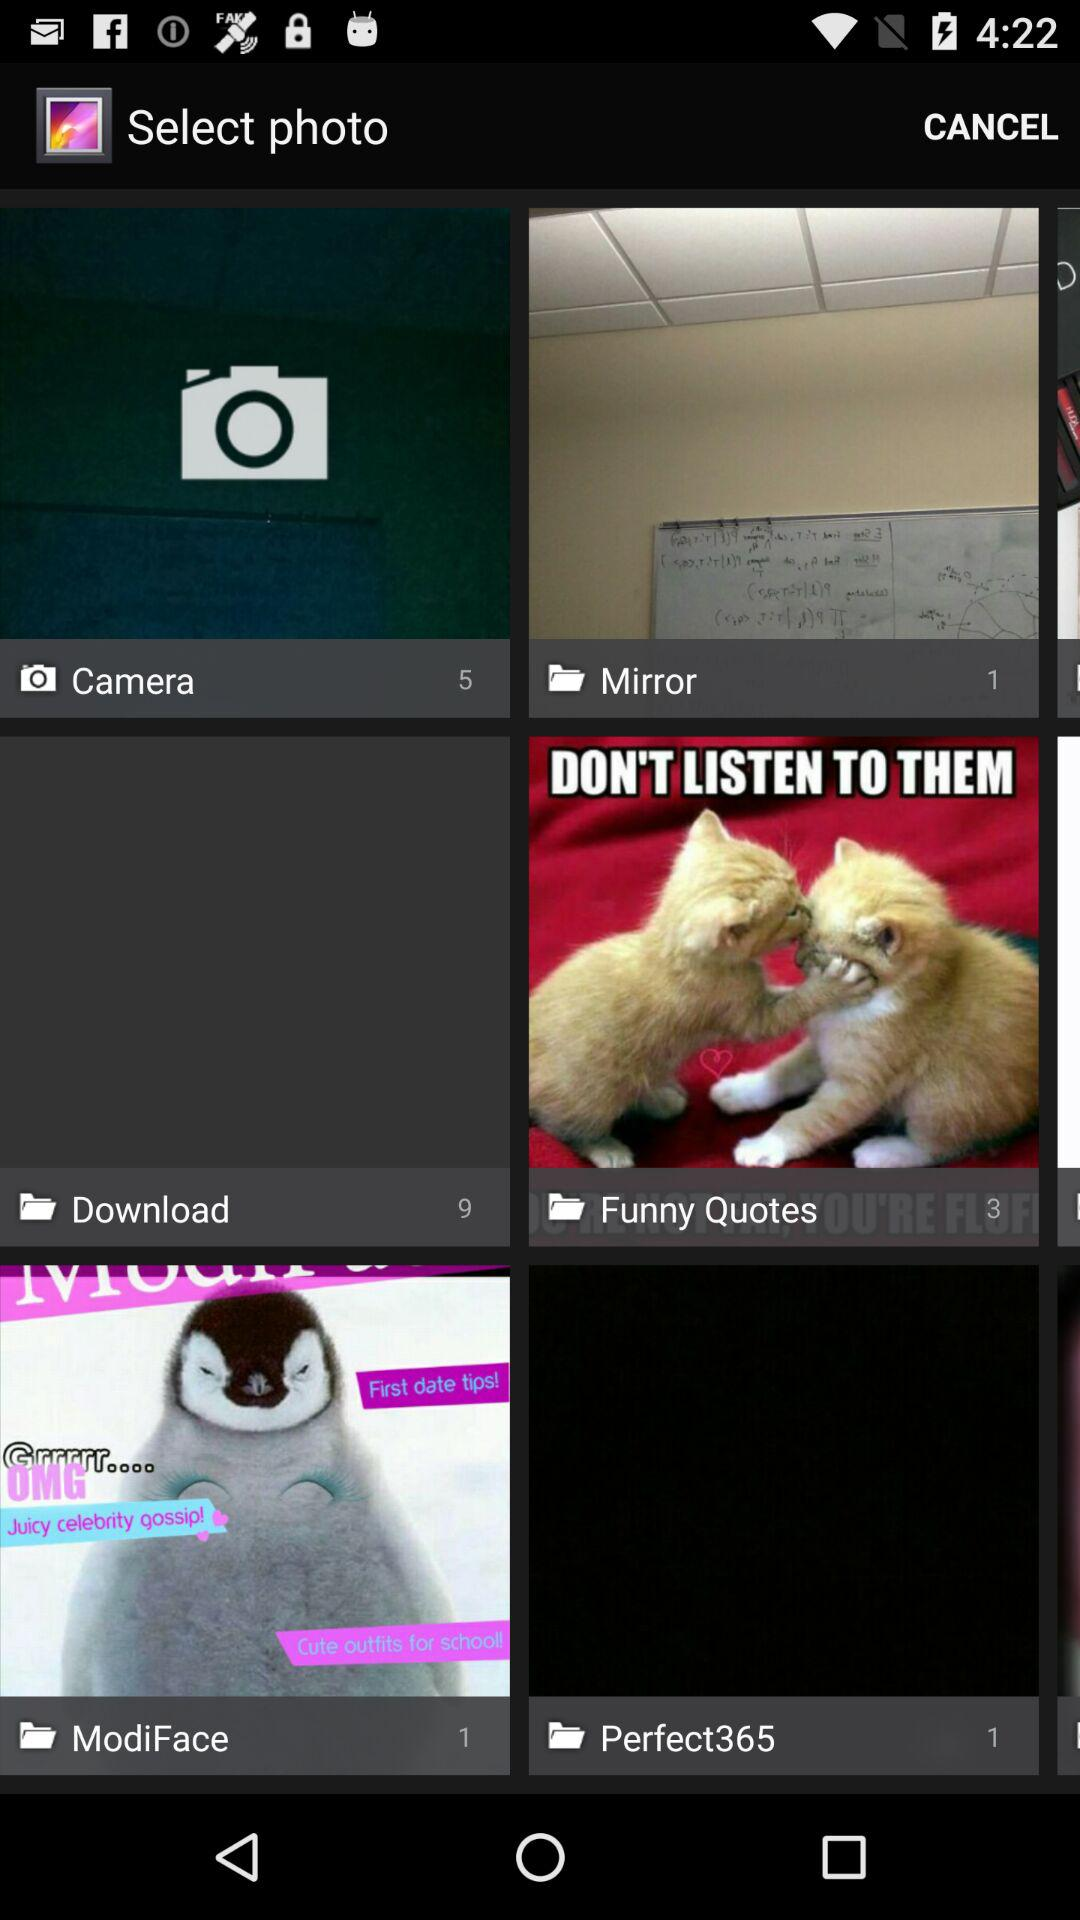How many pictures are in the "Camera" folder? There are 5 pictures in the "Camera" folder. 